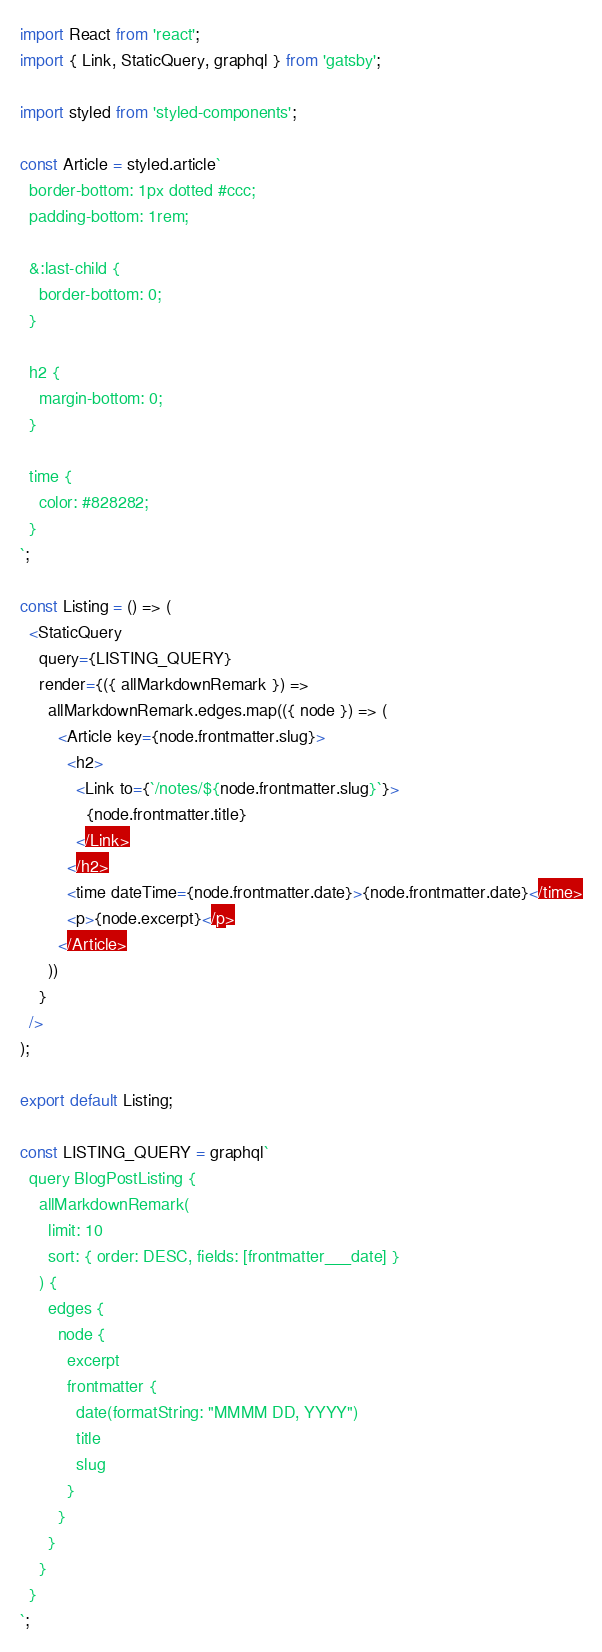Convert code to text. <code><loc_0><loc_0><loc_500><loc_500><_JavaScript_>import React from 'react';
import { Link, StaticQuery, graphql } from 'gatsby';

import styled from 'styled-components';

const Article = styled.article`
  border-bottom: 1px dotted #ccc;
  padding-bottom: 1rem;

  &:last-child {
    border-bottom: 0;
  }

  h2 {
    margin-bottom: 0;
  }

  time {
    color: #828282;
  }
`;

const Listing = () => (
  <StaticQuery
    query={LISTING_QUERY}
    render={({ allMarkdownRemark }) =>
      allMarkdownRemark.edges.map(({ node }) => (
        <Article key={node.frontmatter.slug}>
          <h2>
            <Link to={`/notes/${node.frontmatter.slug}`}>
              {node.frontmatter.title}
            </Link>
          </h2>
          <time dateTime={node.frontmatter.date}>{node.frontmatter.date}</time>
          <p>{node.excerpt}</p>
        </Article>
      ))
    }
  />
);

export default Listing;

const LISTING_QUERY = graphql`
  query BlogPostListing {
    allMarkdownRemark(
      limit: 10
      sort: { order: DESC, fields: [frontmatter___date] }
    ) {
      edges {
        node {
          excerpt
          frontmatter {
            date(formatString: "MMMM DD, YYYY")
            title
            slug
          }
        }
      }
    }
  }
`;
</code> 